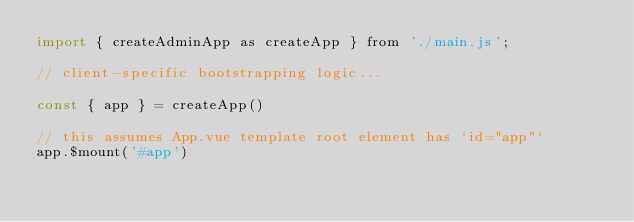Convert code to text. <code><loc_0><loc_0><loc_500><loc_500><_JavaScript_>import { createAdminApp as createApp } from './main.js';

// client-specific bootstrapping logic...

const { app } = createApp()

// this assumes App.vue template root element has `id="app"`
app.$mount('#app')
</code> 